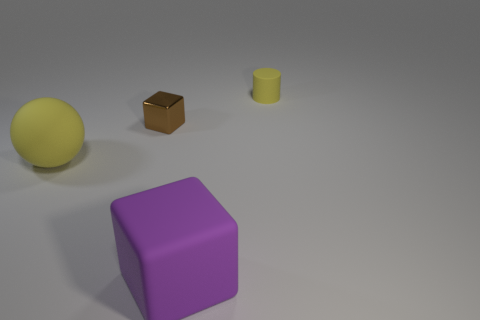How many blocks are in front of the big matte ball?
Provide a short and direct response. 1. How many other objects are the same shape as the tiny matte object?
Your response must be concise. 0. Is the number of big rubber things less than the number of big cyan balls?
Your answer should be compact. No. What size is the object that is both in front of the small metallic cube and to the right of the sphere?
Make the answer very short. Large. What size is the yellow thing that is in front of the yellow matte thing that is to the right of the object left of the small brown metallic thing?
Provide a short and direct response. Large. The brown metallic thing is what size?
Provide a short and direct response. Small. Is there any other thing that has the same material as the brown cube?
Keep it short and to the point. No. Is there a purple block on the right side of the matte thing behind the yellow matte thing that is to the left of the tiny brown object?
Offer a very short reply. No. How many tiny things are purple shiny balls or rubber cylinders?
Provide a succinct answer. 1. Is there anything else that is the same color as the shiny block?
Provide a succinct answer. No. 